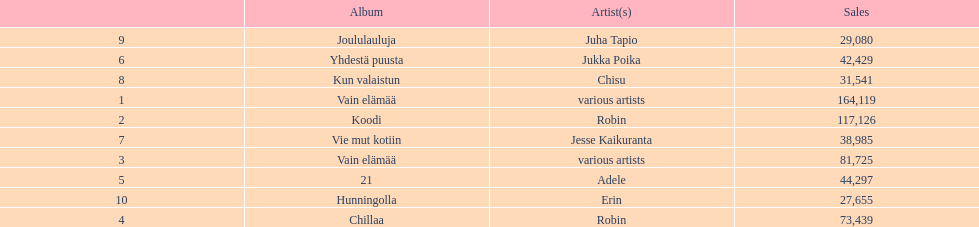Which was better selling, hunningolla or vain elamaa? Vain elämää. 